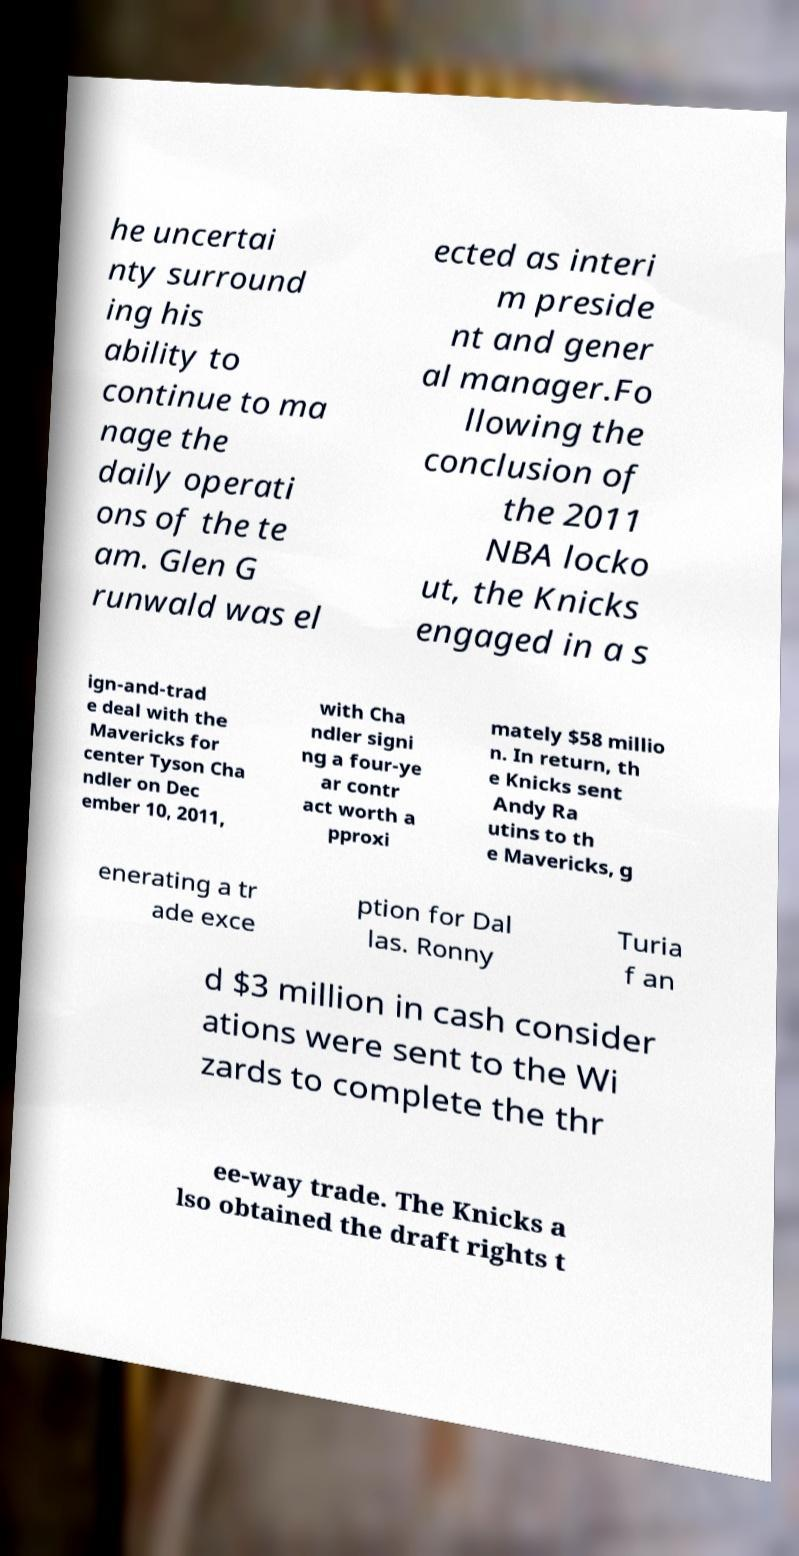Please identify and transcribe the text found in this image. he uncertai nty surround ing his ability to continue to ma nage the daily operati ons of the te am. Glen G runwald was el ected as interi m preside nt and gener al manager.Fo llowing the conclusion of the 2011 NBA locko ut, the Knicks engaged in a s ign-and-trad e deal with the Mavericks for center Tyson Cha ndler on Dec ember 10, 2011, with Cha ndler signi ng a four-ye ar contr act worth a pproxi mately $58 millio n. In return, th e Knicks sent Andy Ra utins to th e Mavericks, g enerating a tr ade exce ption for Dal las. Ronny Turia f an d $3 million in cash consider ations were sent to the Wi zards to complete the thr ee-way trade. The Knicks a lso obtained the draft rights t 